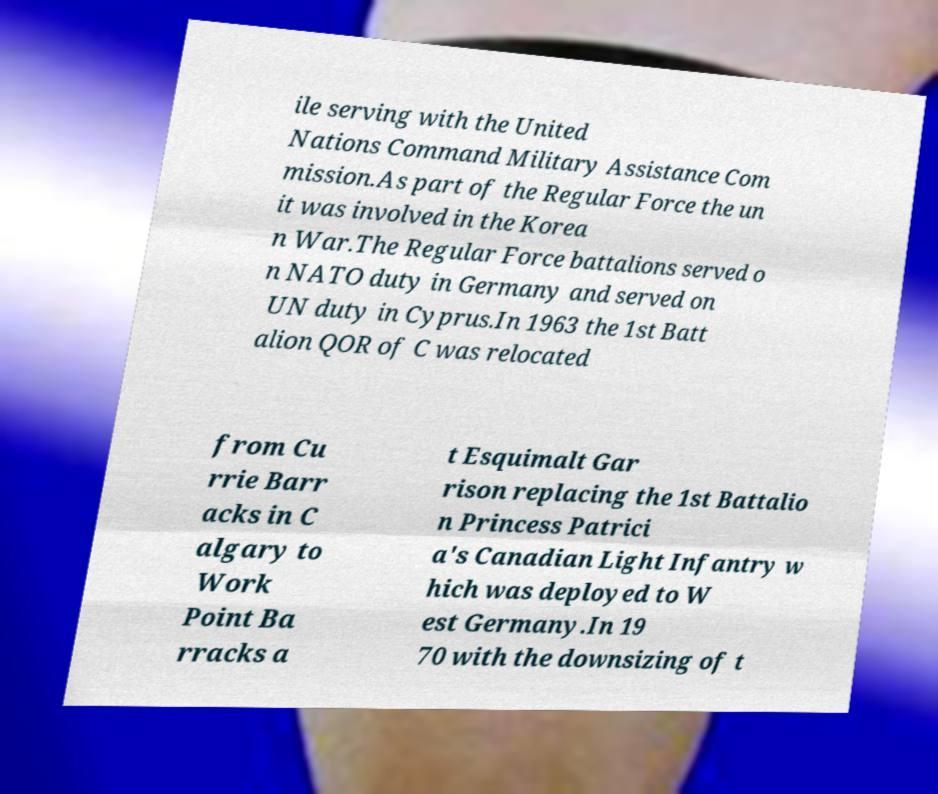Could you extract and type out the text from this image? ile serving with the United Nations Command Military Assistance Com mission.As part of the Regular Force the un it was involved in the Korea n War.The Regular Force battalions served o n NATO duty in Germany and served on UN duty in Cyprus.In 1963 the 1st Batt alion QOR of C was relocated from Cu rrie Barr acks in C algary to Work Point Ba rracks a t Esquimalt Gar rison replacing the 1st Battalio n Princess Patrici a's Canadian Light Infantry w hich was deployed to W est Germany.In 19 70 with the downsizing of t 